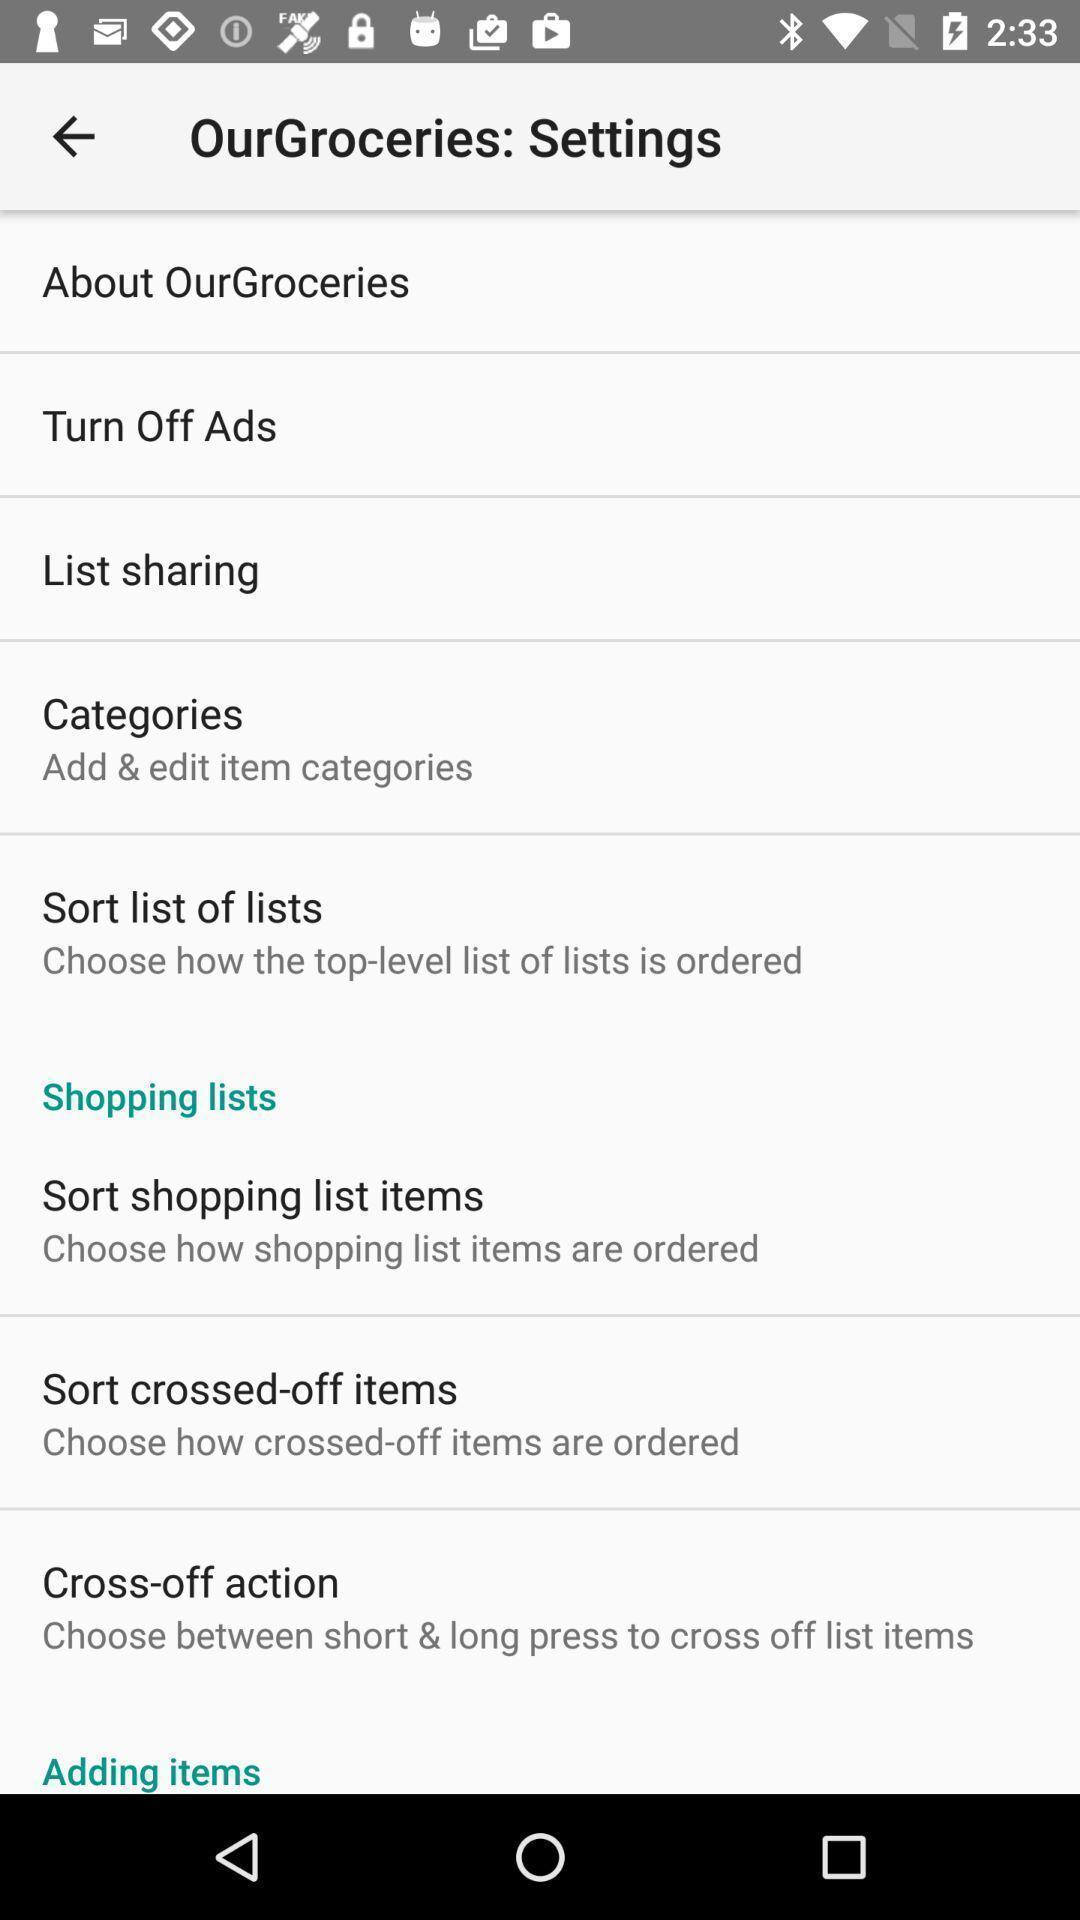Explain the elements present in this screenshot. Settings page. 